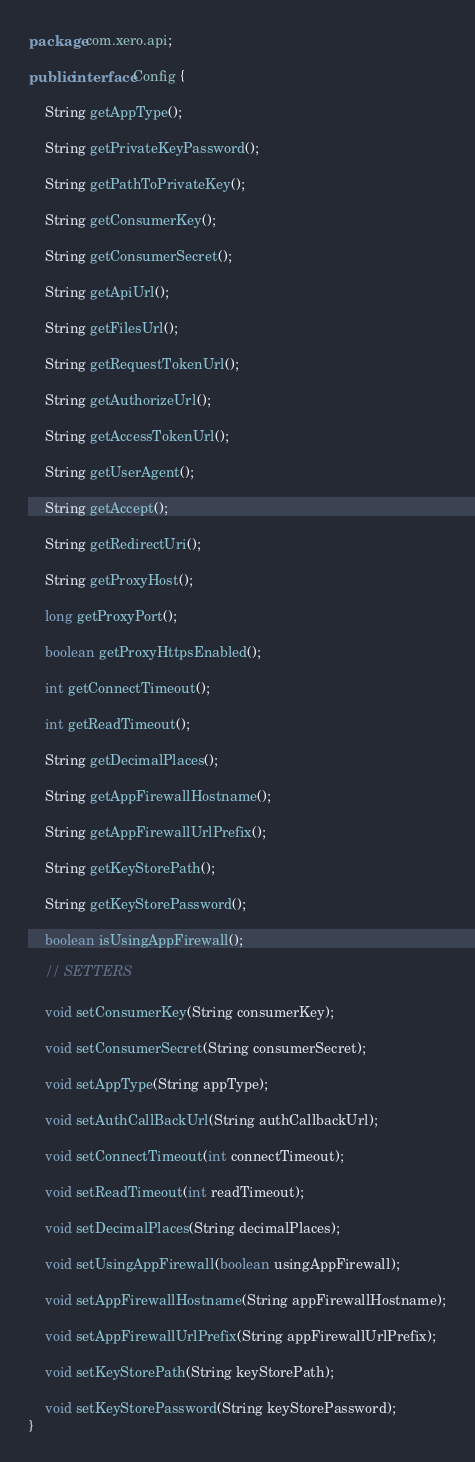Convert code to text. <code><loc_0><loc_0><loc_500><loc_500><_Java_>package com.xero.api;

public interface Config {

    String getAppType();

    String getPrivateKeyPassword();

    String getPathToPrivateKey();

    String getConsumerKey();

    String getConsumerSecret();

    String getApiUrl();

    String getFilesUrl();

    String getRequestTokenUrl();

    String getAuthorizeUrl();

    String getAccessTokenUrl();

    String getUserAgent();

    String getAccept();

    String getRedirectUri();
    
    String getProxyHost();
  
    long getProxyPort();
    
    boolean getProxyHttpsEnabled();
    
    int getConnectTimeout();

    int getReadTimeout();

    String getDecimalPlaces();

    String getAppFirewallHostname();

    String getAppFirewallUrlPrefix();
    
    String getKeyStorePath();
    
    String getKeyStorePassword();

    boolean isUsingAppFirewall();

    // SETTERS

    void setConsumerKey(String consumerKey);

    void setConsumerSecret(String consumerSecret);

    void setAppType(String appType);

    void setAuthCallBackUrl(String authCallbackUrl);

    void setConnectTimeout(int connectTimeout);

    void setReadTimeout(int readTimeout);

    void setDecimalPlaces(String decimalPlaces);

    void setUsingAppFirewall(boolean usingAppFirewall);

    void setAppFirewallHostname(String appFirewallHostname);

    void setAppFirewallUrlPrefix(String appFirewallUrlPrefix);
    
    void setKeyStorePath(String keyStorePath);
    
    void setKeyStorePassword(String keyStorePassword);
}
</code> 